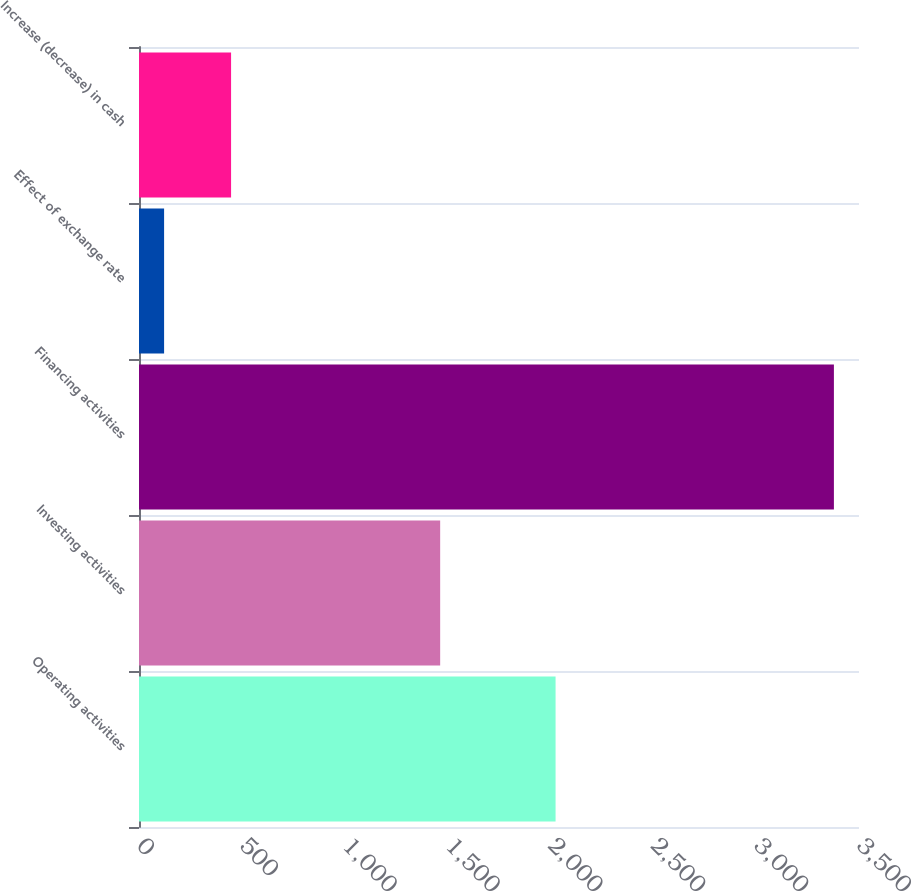Convert chart to OTSL. <chart><loc_0><loc_0><loc_500><loc_500><bar_chart><fcel>Operating activities<fcel>Investing activities<fcel>Financing activities<fcel>Effect of exchange rate<fcel>Increase (decrease) in cash<nl><fcel>2025<fcel>1464<fcel>3378<fcel>122<fcel>447.6<nl></chart> 